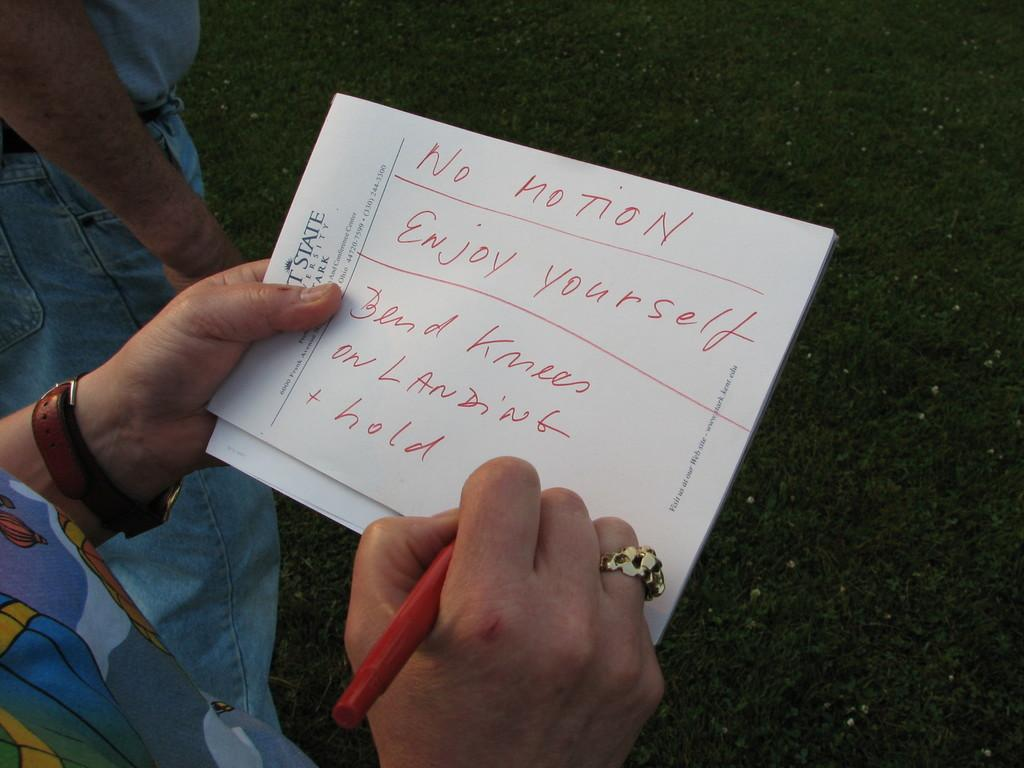Who is present in the image? There is a woman in the image. What is the woman holding in the image? The woman is holding a paper and a pen. Is there anyone else in the image besides the woman? Yes, there is a man standing beside the woman. How many mice are visible in the image? There are no mice present in the image. What is the man's level of wealth in the image? The level of wealth of the man cannot be determined from the image, as there is no information about his financial status. 